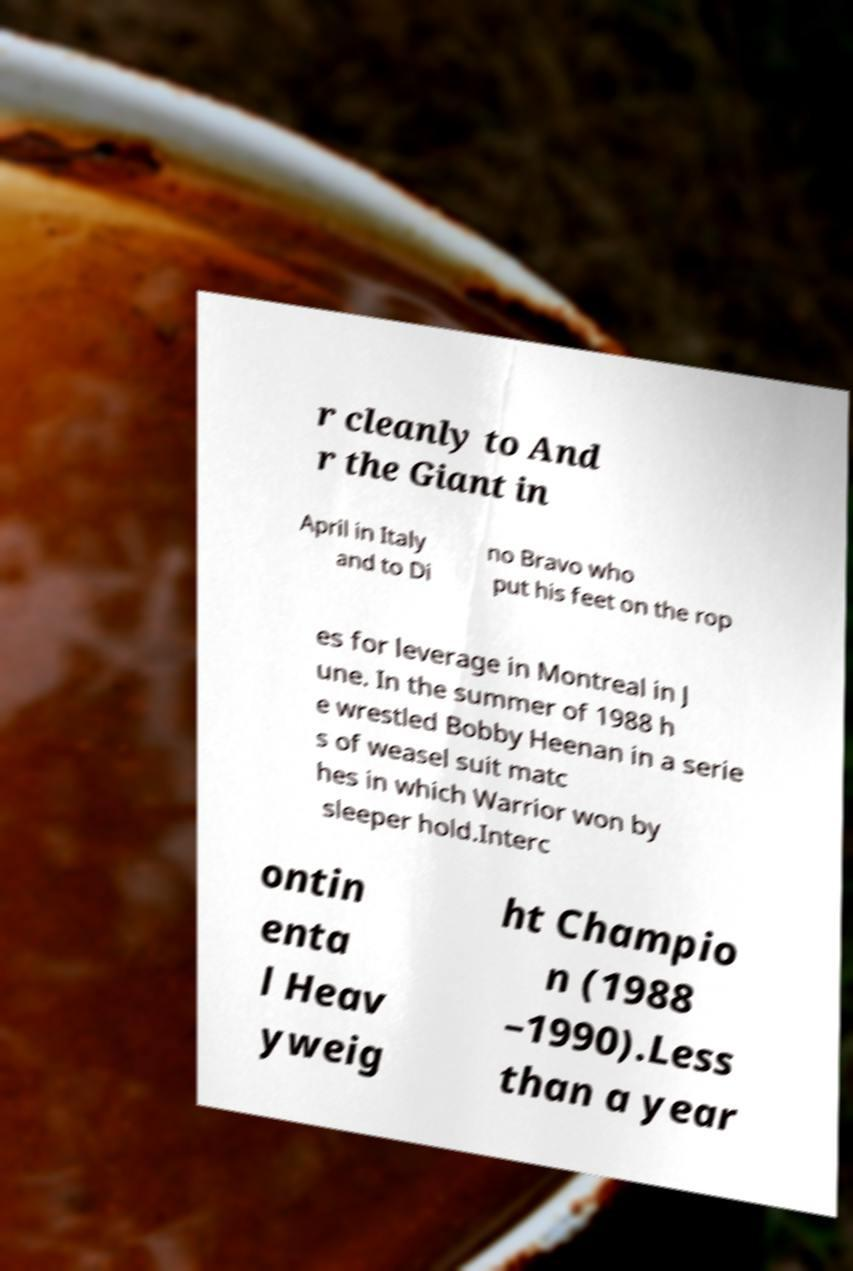There's text embedded in this image that I need extracted. Can you transcribe it verbatim? r cleanly to And r the Giant in April in Italy and to Di no Bravo who put his feet on the rop es for leverage in Montreal in J une. In the summer of 1988 h e wrestled Bobby Heenan in a serie s of weasel suit matc hes in which Warrior won by sleeper hold.Interc ontin enta l Heav yweig ht Champio n (1988 –1990).Less than a year 